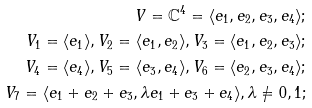<formula> <loc_0><loc_0><loc_500><loc_500>V = \mathbb { C } ^ { 4 } = \langle e _ { 1 } , e _ { 2 } , e _ { 3 } , e _ { 4 } \rangle ; \\ V _ { 1 } = \langle e _ { 1 } \rangle , V _ { 2 } = \langle e _ { 1 } , e _ { 2 } \rangle , V _ { 3 } = \langle e _ { 1 } , e _ { 2 } , e _ { 3 } \rangle ; \\ V _ { 4 } = \langle e _ { 4 } \rangle , V _ { 5 } = \langle e _ { 3 } , e _ { 4 } \rangle , V _ { 6 } = \langle e _ { 2 } , e _ { 3 } , e _ { 4 } \rangle ; \\ V _ { 7 } = \langle e _ { 1 } + e _ { 2 } + e _ { 3 } , \lambda e _ { 1 } + e _ { 3 } + e _ { 4 } \rangle , \lambda \neq 0 , 1 ;</formula> 